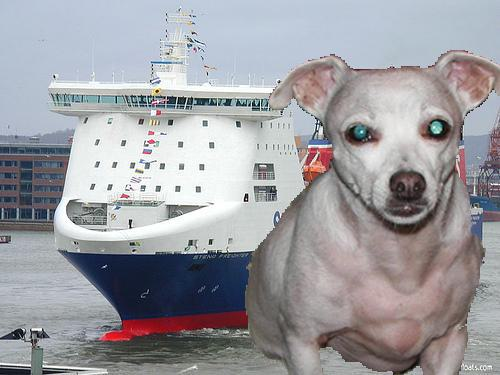Can you describe the dog in the foreground? Certainly, the dog in the foreground is a digitally manipulated image of a small, light-colored dog with bright, unusually colored eyes, possibly indicating that the image has been edited for artistic or humorous effect. 